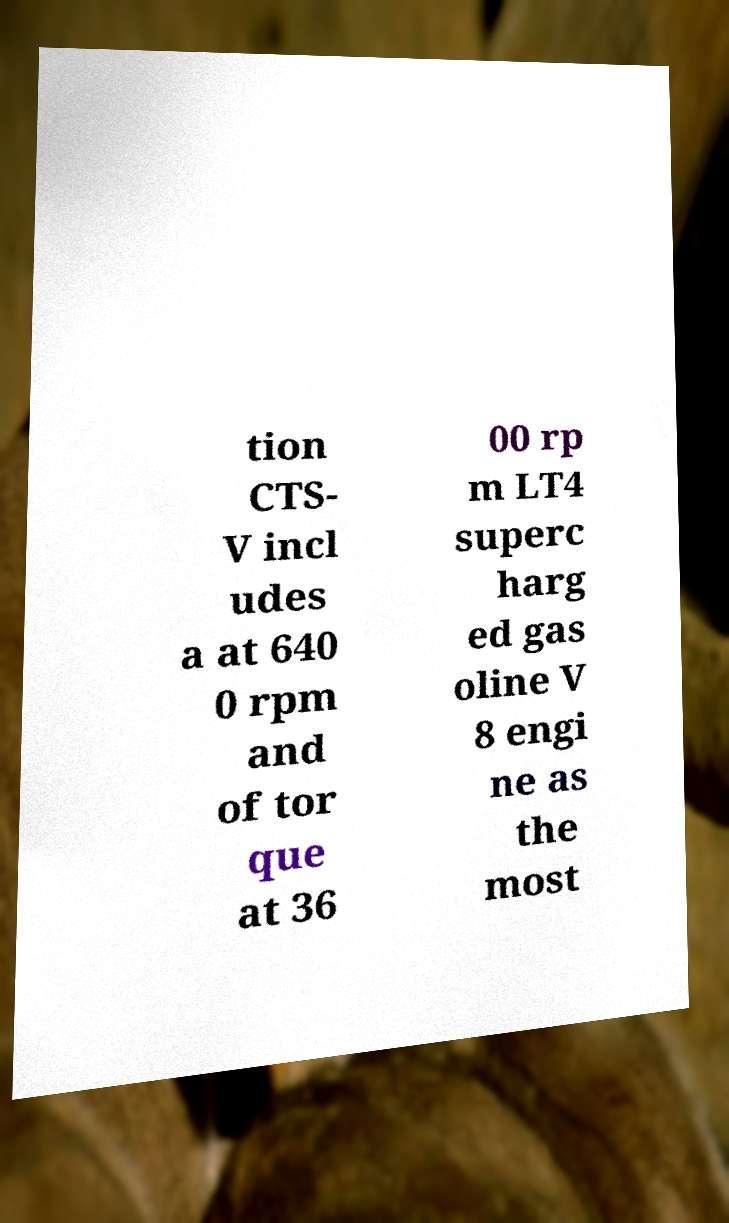What messages or text are displayed in this image? I need them in a readable, typed format. tion CTS- V incl udes a at 640 0 rpm and of tor que at 36 00 rp m LT4 superc harg ed gas oline V 8 engi ne as the most 